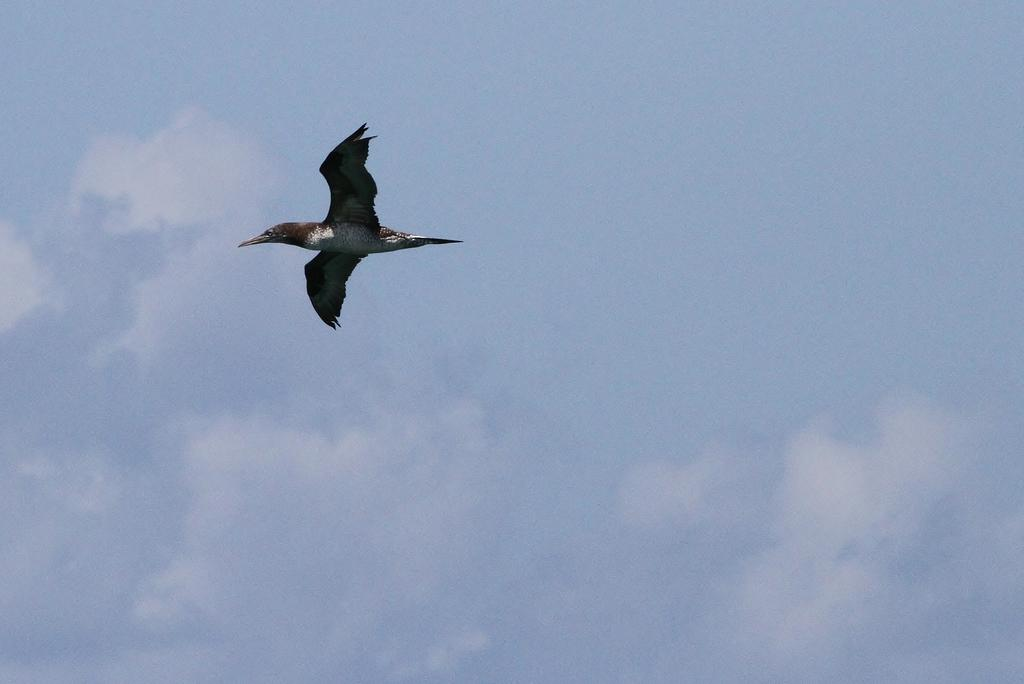What is the bird doing in the image? The bird is flying in the image. Where is the bird located? The bird is in the sky. What else can be seen in the sky in the image? There are clouds visible in the image. What type of payment is the bird making to the clouds in the image? There is no payment being made in the image, as the bird is simply flying in the sky. 